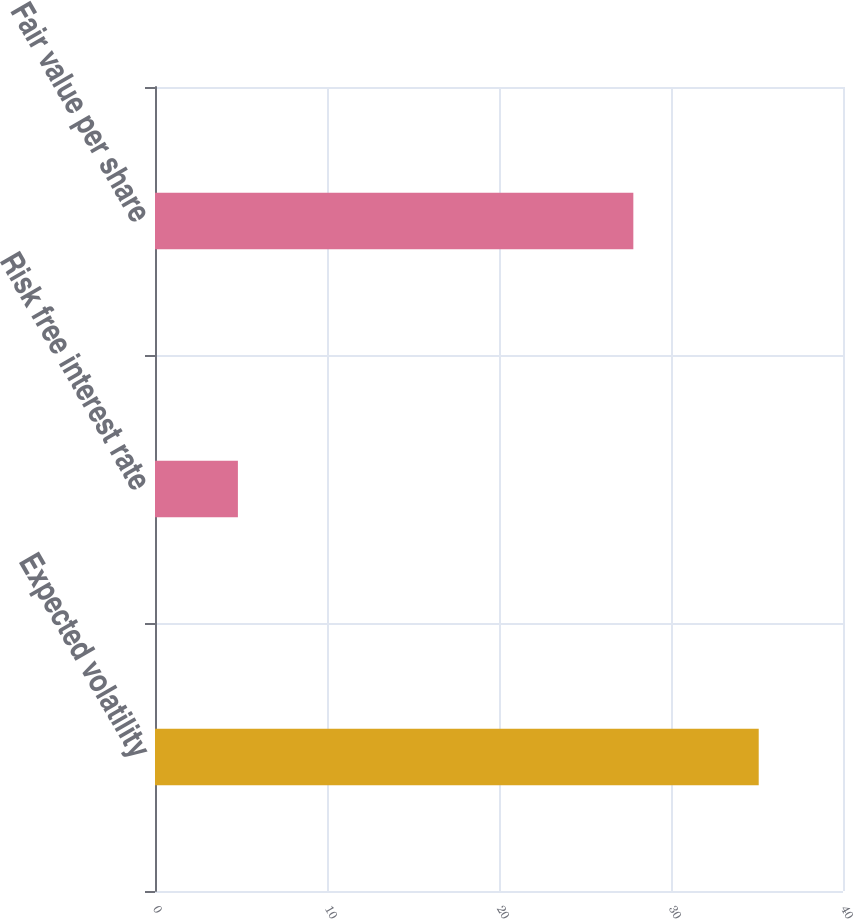Convert chart. <chart><loc_0><loc_0><loc_500><loc_500><bar_chart><fcel>Expected volatility<fcel>Risk free interest rate<fcel>Fair value per share<nl><fcel>35.1<fcel>4.82<fcel>27.81<nl></chart> 